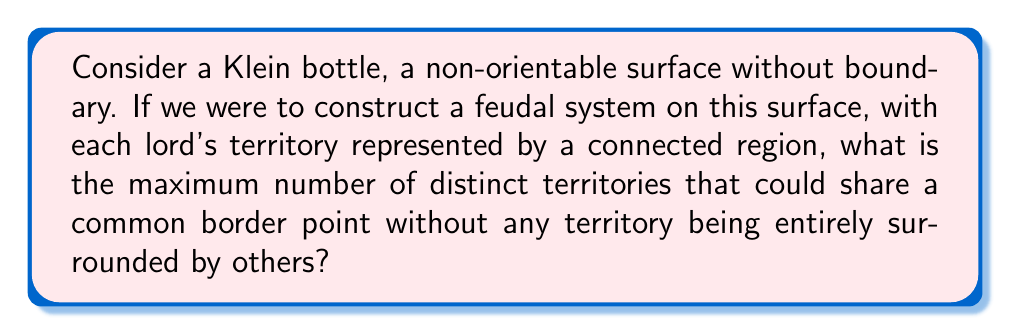What is the answer to this math problem? To answer this question, we need to analyze the topological properties of a Klein bottle:

1. The Klein bottle is a closed, non-orientable surface with no boundary.

2. It can be represented in 3D space by passing a tube through itself, but it actually exists in 4D space without self-intersection.

3. Topologically, it's equivalent to gluing two Möbius strips along their boundaries.

Now, let's consider the properties relevant to our question:

4. The Klein bottle has a Euler characteristic $\chi = 0$.

5. It's a 2-dimensional manifold, so each point on the surface has a neighborhood homeomorphic to a 2D disk.

6. Unlike a sphere or torus, the Klein bottle is non-orientable, which affects how regions can be arranged on its surface.

To maximize the number of territories sharing a common border point:

7. We need to arrange the territories radially around a single point.

8. Each territory must touch this central point and its two adjacent territories.

9. The key constraint is that no territory can be entirely surrounded by others, as this would violate the conditions of our feudal system.

10. Due to the non-orientability of the Klein bottle, we can actually arrange 4 territories around a single point without any being completely surrounded.

This is possible because:

11. As we go around the point, we can "flip" the orientation, allowing the fourth territory to connect back to the first without surrounding any other territory completely.

12. This configuration takes advantage of the Klein bottle's unique topology, which allows for connections that wouldn't be possible on a simpler surface like a sphere or torus.

[asy]
import geometry;

unitsize(1cm);

path p1 = (0,0)--(2,0)--(2,2)--(0,2)--cycle;
path p2 = (0,0)--(0,-2)--(-2,-2)--(-2,0)--cycle;
path p3 = (0,0)--(-2,0)--(-2,2)--(0,2)--cycle;
path p4 = (0,0)--(2,0)--(2,-2)--(0,-2)--cycle;

fill(p1, rgb(0.9,0.7,0.7));
fill(p2, rgb(0.7,0.9,0.7));
fill(p3, rgb(0.7,0.7,0.9));
fill(p4, rgb(0.9,0.9,0.7));

draw(p1);
draw(p2);
draw(p3);
draw(p4);

label("1", (1,1));
label("2", (-1,-1));
label("3", (-1,1));
label("4", (1,-1));

dot((0,0));
label("Common Point", (0,-2.5));
Answer: The maximum number of distinct territories that could share a common border point on a Klein bottle without any territory being entirely surrounded by others is 4. 